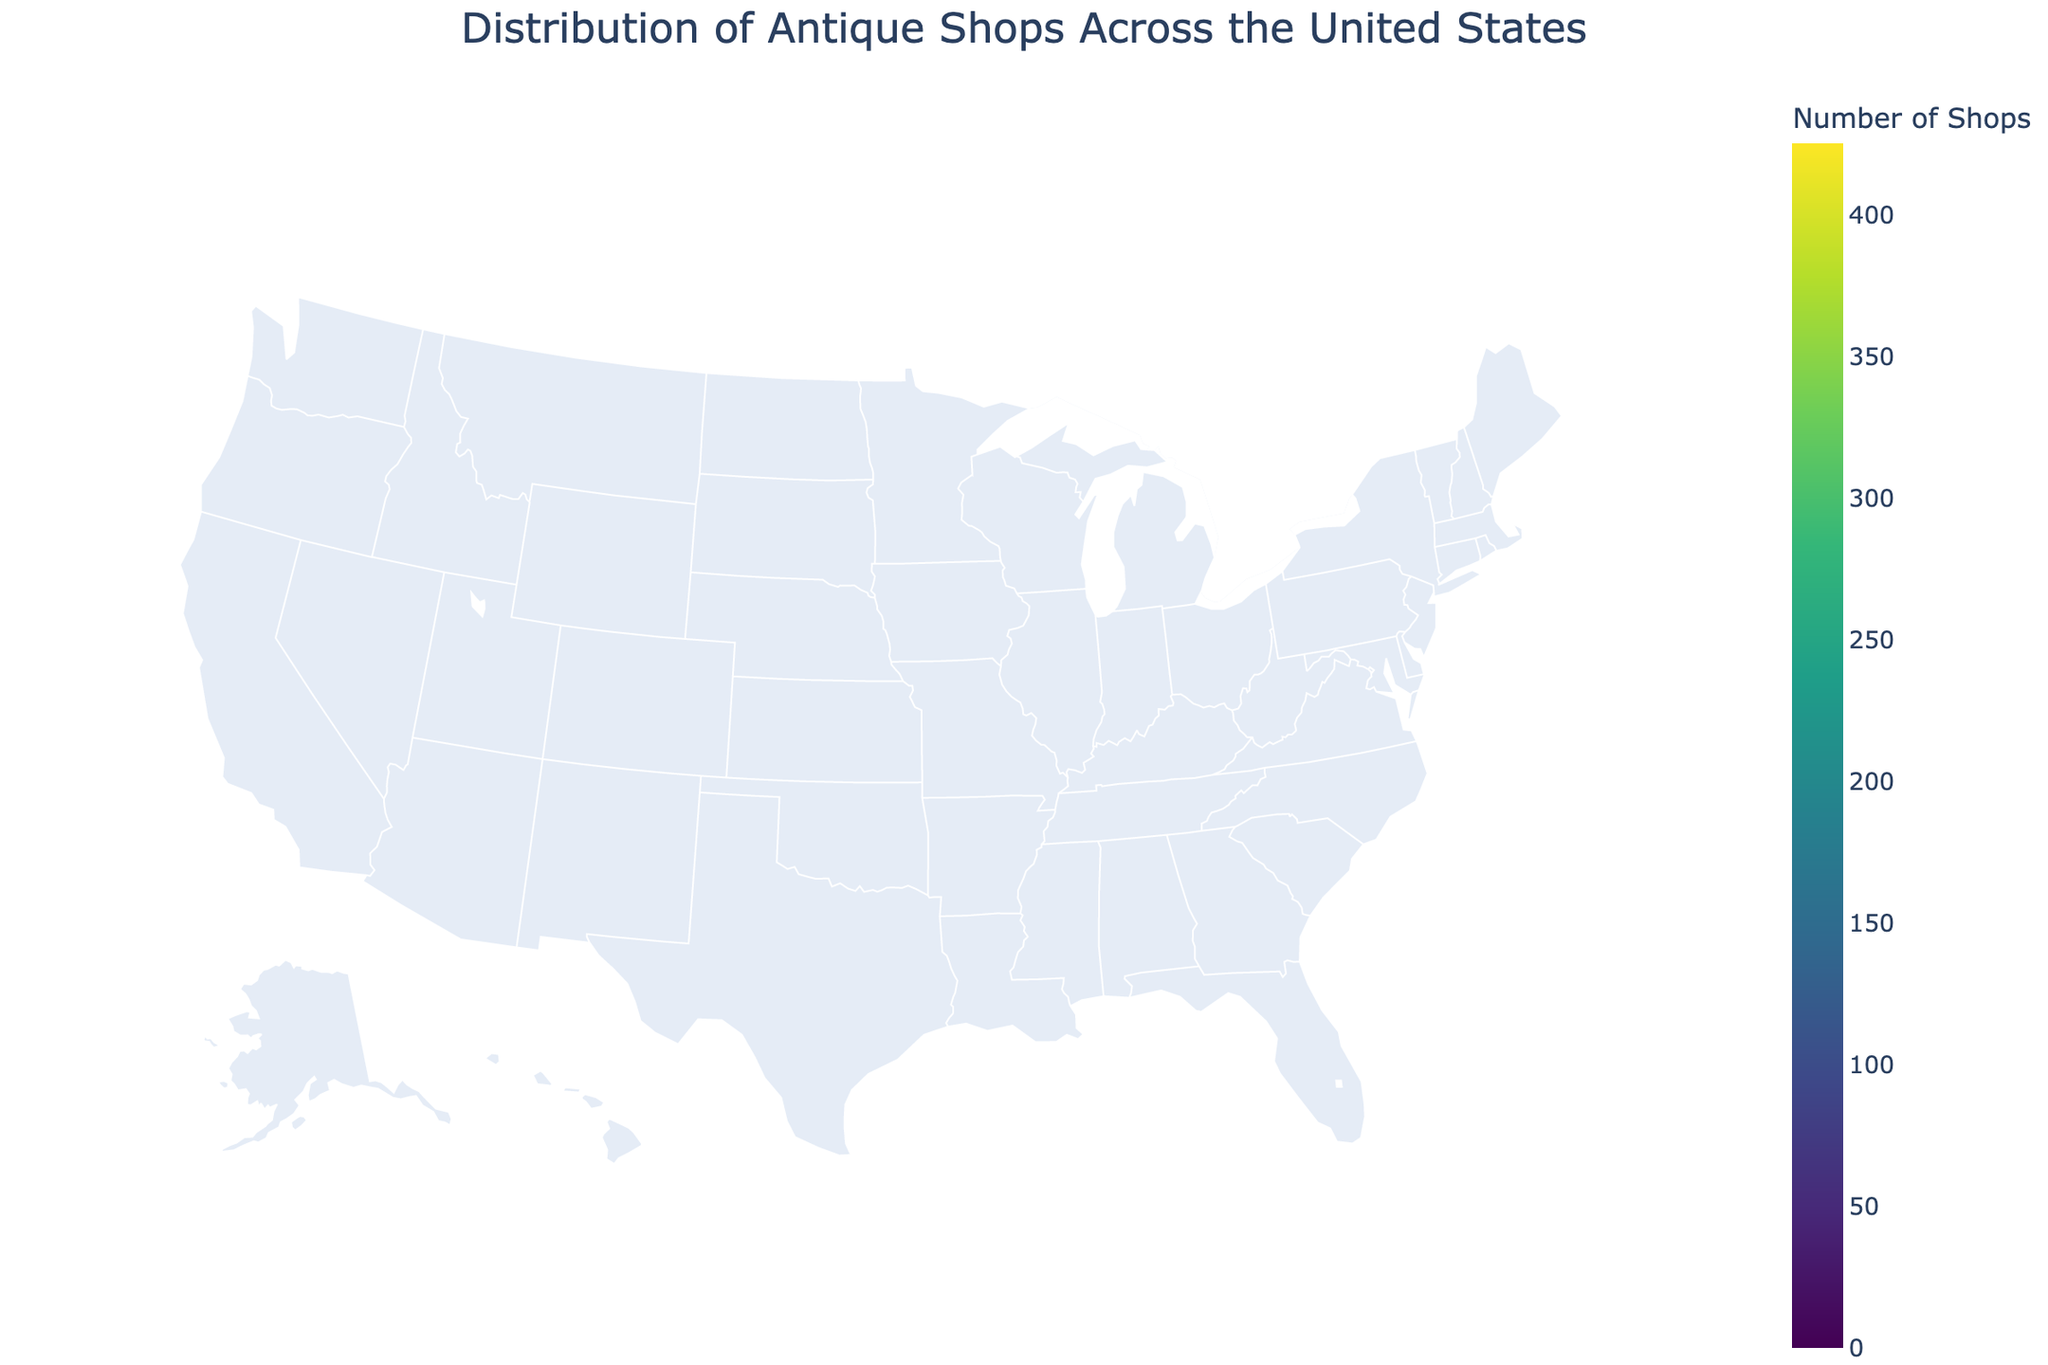How many antique shops are there in California? From the plot, we can see that the color intensity for California indicates the highest number of antique shops. Hovering over California shows that it has 425 antique shops.
Answer: 425 Which state has the fewest antique shops among those shown on the map? Reviewing the color intensities and the hover information, Connecticut appears to have the fewest shops with 105.
Answer: Connecticut What region of the United States shows the highest concentration of antique shops? The plot displays the highest concentrations of antique shops in the Eastern and Western coasts, particularly in states like California and New York.
Answer: Eastern and Western coasts How many more antique shops are there in New York compared to Georgia? New York has 380 shops and Georgia has 190. The difference is 380 - 190 = 190 antique shops.
Answer: 190 Which states have between 200 and 300 antique shops? From the hover information on the plot, Pennsylvania, Ohio, Illinois, and Michigan all fall within this range.
Answer: Pennsylvania, Ohio, Illinois, Michigan Is there a noticeable pattern in the distribution of antique shops across the United States? Yes, coastal states and more populous areas tend to have more antique shops, as indicated by the darker colors on the coasts and the Eastern half of the map.
Answer: Yes Which state has the second-highest number of antique shops? From the hover data, New York has the second-highest number of antique shops with 380, after California.
Answer: New York How does the number of antique shops in Florida compare to that in Pennsylvania? Florida has 320 antique shops, and Pennsylvania has 290. Florida has more shops than Pennsylvania by a difference of 320 - 290 = 30.
Answer: 30 In the middle of the United States, which state shows the highest number of antique shops? Among the central states, Texas stands out with 350 antique shops as indicated by the hovering data.
Answer: Texas What can be inferred about the popularity of antique shops in the Midwest compared to the coastal areas? The Midwest shows fewer antique shops compared to the coastal areas, as indicated by lighter colors on the map in states like Indiana and Missouri compared to California and New York.
Answer: Coastal areas have more shops 